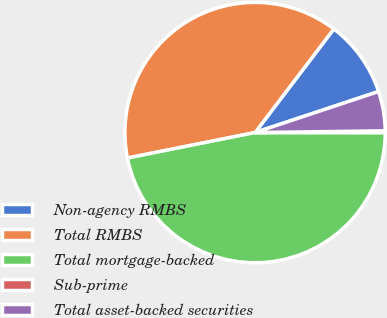Convert chart. <chart><loc_0><loc_0><loc_500><loc_500><pie_chart><fcel>Non-agency RMBS<fcel>Total RMBS<fcel>Total mortgage-backed<fcel>Sub-prime<fcel>Total asset-backed securities<nl><fcel>9.55%<fcel>38.48%<fcel>46.86%<fcel>0.22%<fcel>4.89%<nl></chart> 